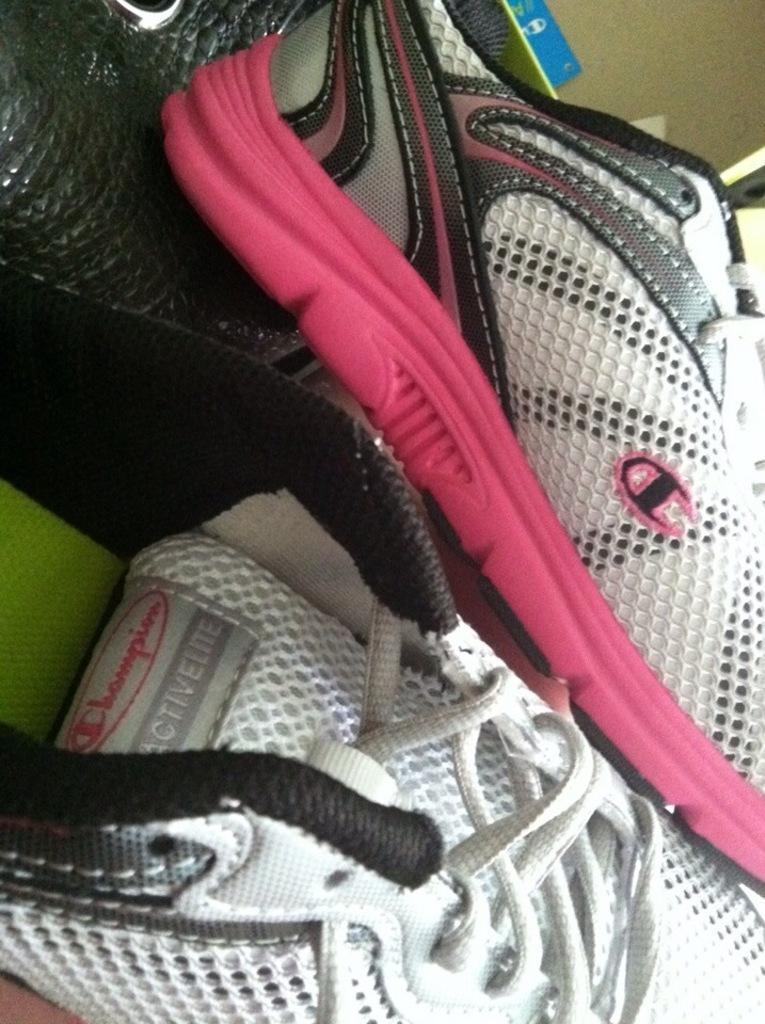Could you give a brief overview of what you see in this image? In the foreground of this image, there are shoes. 